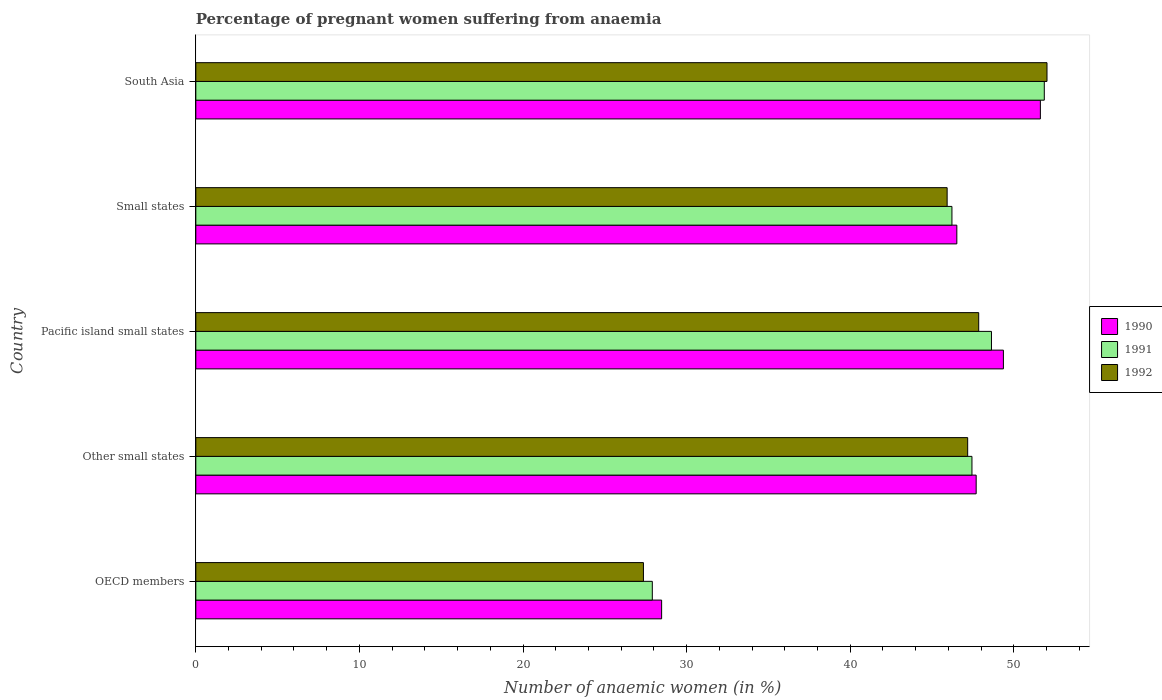How many groups of bars are there?
Your response must be concise. 5. How many bars are there on the 2nd tick from the top?
Give a very brief answer. 3. What is the label of the 5th group of bars from the top?
Your response must be concise. OECD members. In how many cases, is the number of bars for a given country not equal to the number of legend labels?
Ensure brevity in your answer.  0. What is the number of anaemic women in 1992 in Small states?
Ensure brevity in your answer.  45.93. Across all countries, what is the maximum number of anaemic women in 1992?
Keep it short and to the point. 52.03. Across all countries, what is the minimum number of anaemic women in 1992?
Offer a terse response. 27.36. What is the total number of anaemic women in 1992 in the graph?
Offer a terse response. 220.36. What is the difference between the number of anaemic women in 1992 in Other small states and that in Small states?
Ensure brevity in your answer.  1.26. What is the difference between the number of anaemic women in 1992 in Other small states and the number of anaemic women in 1991 in OECD members?
Provide a short and direct response. 19.28. What is the average number of anaemic women in 1992 per country?
Your response must be concise. 44.07. What is the difference between the number of anaemic women in 1992 and number of anaemic women in 1990 in OECD members?
Your answer should be compact. -1.11. In how many countries, is the number of anaemic women in 1991 greater than 52 %?
Offer a terse response. 0. What is the ratio of the number of anaemic women in 1990 in Pacific island small states to that in South Asia?
Give a very brief answer. 0.96. Is the number of anaemic women in 1991 in Other small states less than that in Pacific island small states?
Ensure brevity in your answer.  Yes. Is the difference between the number of anaemic women in 1992 in Other small states and South Asia greater than the difference between the number of anaemic women in 1990 in Other small states and South Asia?
Your answer should be compact. No. What is the difference between the highest and the second highest number of anaemic women in 1992?
Make the answer very short. 4.17. What is the difference between the highest and the lowest number of anaemic women in 1990?
Ensure brevity in your answer.  23.15. In how many countries, is the number of anaemic women in 1991 greater than the average number of anaemic women in 1991 taken over all countries?
Your answer should be very brief. 4. What does the 3rd bar from the bottom in Other small states represents?
Ensure brevity in your answer.  1992. How many bars are there?
Ensure brevity in your answer.  15. How many countries are there in the graph?
Provide a short and direct response. 5. Are the values on the major ticks of X-axis written in scientific E-notation?
Your answer should be compact. No. Does the graph contain grids?
Offer a terse response. No. Where does the legend appear in the graph?
Provide a short and direct response. Center right. What is the title of the graph?
Give a very brief answer. Percentage of pregnant women suffering from anaemia. What is the label or title of the X-axis?
Your answer should be very brief. Number of anaemic women (in %). What is the Number of anaemic women (in %) in 1990 in OECD members?
Provide a succinct answer. 28.47. What is the Number of anaemic women (in %) of 1991 in OECD members?
Your answer should be compact. 27.9. What is the Number of anaemic women (in %) of 1992 in OECD members?
Ensure brevity in your answer.  27.36. What is the Number of anaemic women (in %) of 1990 in Other small states?
Provide a succinct answer. 47.7. What is the Number of anaemic women (in %) of 1991 in Other small states?
Offer a very short reply. 47.44. What is the Number of anaemic women (in %) of 1992 in Other small states?
Your answer should be very brief. 47.18. What is the Number of anaemic women (in %) of 1990 in Pacific island small states?
Your response must be concise. 49.37. What is the Number of anaemic women (in %) in 1991 in Pacific island small states?
Provide a succinct answer. 48.64. What is the Number of anaemic women (in %) of 1992 in Pacific island small states?
Ensure brevity in your answer.  47.86. What is the Number of anaemic women (in %) of 1990 in Small states?
Ensure brevity in your answer.  46.52. What is the Number of anaemic women (in %) in 1991 in Small states?
Provide a succinct answer. 46.22. What is the Number of anaemic women (in %) in 1992 in Small states?
Provide a succinct answer. 45.93. What is the Number of anaemic women (in %) of 1990 in South Asia?
Keep it short and to the point. 51.63. What is the Number of anaemic women (in %) in 1991 in South Asia?
Keep it short and to the point. 51.87. What is the Number of anaemic women (in %) in 1992 in South Asia?
Make the answer very short. 52.03. Across all countries, what is the maximum Number of anaemic women (in %) in 1990?
Provide a short and direct response. 51.63. Across all countries, what is the maximum Number of anaemic women (in %) in 1991?
Your response must be concise. 51.87. Across all countries, what is the maximum Number of anaemic women (in %) of 1992?
Make the answer very short. 52.03. Across all countries, what is the minimum Number of anaemic women (in %) of 1990?
Your response must be concise. 28.47. Across all countries, what is the minimum Number of anaemic women (in %) of 1991?
Ensure brevity in your answer.  27.9. Across all countries, what is the minimum Number of anaemic women (in %) in 1992?
Your answer should be very brief. 27.36. What is the total Number of anaemic women (in %) of 1990 in the graph?
Provide a succinct answer. 223.69. What is the total Number of anaemic women (in %) in 1991 in the graph?
Your answer should be compact. 222.07. What is the total Number of anaemic women (in %) in 1992 in the graph?
Your answer should be compact. 220.36. What is the difference between the Number of anaemic women (in %) in 1990 in OECD members and that in Other small states?
Your answer should be compact. -19.23. What is the difference between the Number of anaemic women (in %) in 1991 in OECD members and that in Other small states?
Make the answer very short. -19.54. What is the difference between the Number of anaemic women (in %) of 1992 in OECD members and that in Other small states?
Give a very brief answer. -19.82. What is the difference between the Number of anaemic women (in %) of 1990 in OECD members and that in Pacific island small states?
Provide a short and direct response. -20.89. What is the difference between the Number of anaemic women (in %) of 1991 in OECD members and that in Pacific island small states?
Provide a succinct answer. -20.73. What is the difference between the Number of anaemic women (in %) in 1992 in OECD members and that in Pacific island small states?
Your response must be concise. -20.49. What is the difference between the Number of anaemic women (in %) of 1990 in OECD members and that in Small states?
Your answer should be compact. -18.05. What is the difference between the Number of anaemic women (in %) in 1991 in OECD members and that in Small states?
Your answer should be very brief. -18.32. What is the difference between the Number of anaemic women (in %) in 1992 in OECD members and that in Small states?
Ensure brevity in your answer.  -18.57. What is the difference between the Number of anaemic women (in %) in 1990 in OECD members and that in South Asia?
Keep it short and to the point. -23.15. What is the difference between the Number of anaemic women (in %) of 1991 in OECD members and that in South Asia?
Provide a short and direct response. -23.96. What is the difference between the Number of anaemic women (in %) of 1992 in OECD members and that in South Asia?
Offer a terse response. -24.67. What is the difference between the Number of anaemic women (in %) in 1990 in Other small states and that in Pacific island small states?
Your response must be concise. -1.66. What is the difference between the Number of anaemic women (in %) in 1991 in Other small states and that in Pacific island small states?
Ensure brevity in your answer.  -1.19. What is the difference between the Number of anaemic women (in %) of 1992 in Other small states and that in Pacific island small states?
Your response must be concise. -0.67. What is the difference between the Number of anaemic women (in %) in 1990 in Other small states and that in Small states?
Provide a succinct answer. 1.18. What is the difference between the Number of anaemic women (in %) of 1991 in Other small states and that in Small states?
Ensure brevity in your answer.  1.22. What is the difference between the Number of anaemic women (in %) in 1992 in Other small states and that in Small states?
Your response must be concise. 1.26. What is the difference between the Number of anaemic women (in %) of 1990 in Other small states and that in South Asia?
Your answer should be compact. -3.92. What is the difference between the Number of anaemic women (in %) of 1991 in Other small states and that in South Asia?
Your answer should be compact. -4.42. What is the difference between the Number of anaemic women (in %) in 1992 in Other small states and that in South Asia?
Your answer should be compact. -4.85. What is the difference between the Number of anaemic women (in %) in 1990 in Pacific island small states and that in Small states?
Offer a terse response. 2.85. What is the difference between the Number of anaemic women (in %) in 1991 in Pacific island small states and that in Small states?
Keep it short and to the point. 2.42. What is the difference between the Number of anaemic women (in %) in 1992 in Pacific island small states and that in Small states?
Offer a very short reply. 1.93. What is the difference between the Number of anaemic women (in %) of 1990 in Pacific island small states and that in South Asia?
Keep it short and to the point. -2.26. What is the difference between the Number of anaemic women (in %) of 1991 in Pacific island small states and that in South Asia?
Your response must be concise. -3.23. What is the difference between the Number of anaemic women (in %) in 1992 in Pacific island small states and that in South Asia?
Your answer should be very brief. -4.17. What is the difference between the Number of anaemic women (in %) in 1990 in Small states and that in South Asia?
Your answer should be compact. -5.11. What is the difference between the Number of anaemic women (in %) of 1991 in Small states and that in South Asia?
Offer a terse response. -5.65. What is the difference between the Number of anaemic women (in %) of 1992 in Small states and that in South Asia?
Your answer should be compact. -6.1. What is the difference between the Number of anaemic women (in %) of 1990 in OECD members and the Number of anaemic women (in %) of 1991 in Other small states?
Keep it short and to the point. -18.97. What is the difference between the Number of anaemic women (in %) of 1990 in OECD members and the Number of anaemic women (in %) of 1992 in Other small states?
Your response must be concise. -18.71. What is the difference between the Number of anaemic women (in %) in 1991 in OECD members and the Number of anaemic women (in %) in 1992 in Other small states?
Provide a short and direct response. -19.28. What is the difference between the Number of anaemic women (in %) of 1990 in OECD members and the Number of anaemic women (in %) of 1991 in Pacific island small states?
Offer a very short reply. -20.16. What is the difference between the Number of anaemic women (in %) of 1990 in OECD members and the Number of anaemic women (in %) of 1992 in Pacific island small states?
Your answer should be very brief. -19.38. What is the difference between the Number of anaemic women (in %) of 1991 in OECD members and the Number of anaemic women (in %) of 1992 in Pacific island small states?
Your answer should be very brief. -19.95. What is the difference between the Number of anaemic women (in %) of 1990 in OECD members and the Number of anaemic women (in %) of 1991 in Small states?
Your answer should be very brief. -17.75. What is the difference between the Number of anaemic women (in %) of 1990 in OECD members and the Number of anaemic women (in %) of 1992 in Small states?
Offer a very short reply. -17.45. What is the difference between the Number of anaemic women (in %) in 1991 in OECD members and the Number of anaemic women (in %) in 1992 in Small states?
Provide a succinct answer. -18.02. What is the difference between the Number of anaemic women (in %) of 1990 in OECD members and the Number of anaemic women (in %) of 1991 in South Asia?
Your answer should be compact. -23.39. What is the difference between the Number of anaemic women (in %) of 1990 in OECD members and the Number of anaemic women (in %) of 1992 in South Asia?
Your response must be concise. -23.56. What is the difference between the Number of anaemic women (in %) in 1991 in OECD members and the Number of anaemic women (in %) in 1992 in South Asia?
Provide a succinct answer. -24.13. What is the difference between the Number of anaemic women (in %) of 1990 in Other small states and the Number of anaemic women (in %) of 1991 in Pacific island small states?
Your answer should be compact. -0.94. What is the difference between the Number of anaemic women (in %) in 1990 in Other small states and the Number of anaemic women (in %) in 1992 in Pacific island small states?
Your answer should be compact. -0.15. What is the difference between the Number of anaemic women (in %) of 1991 in Other small states and the Number of anaemic women (in %) of 1992 in Pacific island small states?
Your response must be concise. -0.41. What is the difference between the Number of anaemic women (in %) in 1990 in Other small states and the Number of anaemic women (in %) in 1991 in Small states?
Make the answer very short. 1.48. What is the difference between the Number of anaemic women (in %) of 1990 in Other small states and the Number of anaemic women (in %) of 1992 in Small states?
Keep it short and to the point. 1.77. What is the difference between the Number of anaemic women (in %) in 1991 in Other small states and the Number of anaemic women (in %) in 1992 in Small states?
Give a very brief answer. 1.52. What is the difference between the Number of anaemic women (in %) of 1990 in Other small states and the Number of anaemic women (in %) of 1991 in South Asia?
Provide a succinct answer. -4.16. What is the difference between the Number of anaemic women (in %) in 1990 in Other small states and the Number of anaemic women (in %) in 1992 in South Asia?
Provide a short and direct response. -4.33. What is the difference between the Number of anaemic women (in %) in 1991 in Other small states and the Number of anaemic women (in %) in 1992 in South Asia?
Offer a terse response. -4.59. What is the difference between the Number of anaemic women (in %) of 1990 in Pacific island small states and the Number of anaemic women (in %) of 1991 in Small states?
Offer a terse response. 3.15. What is the difference between the Number of anaemic women (in %) in 1990 in Pacific island small states and the Number of anaemic women (in %) in 1992 in Small states?
Make the answer very short. 3.44. What is the difference between the Number of anaemic women (in %) of 1991 in Pacific island small states and the Number of anaemic women (in %) of 1992 in Small states?
Provide a succinct answer. 2.71. What is the difference between the Number of anaemic women (in %) of 1990 in Pacific island small states and the Number of anaemic women (in %) of 1991 in South Asia?
Provide a short and direct response. -2.5. What is the difference between the Number of anaemic women (in %) of 1990 in Pacific island small states and the Number of anaemic women (in %) of 1992 in South Asia?
Offer a very short reply. -2.66. What is the difference between the Number of anaemic women (in %) of 1991 in Pacific island small states and the Number of anaemic women (in %) of 1992 in South Asia?
Offer a terse response. -3.39. What is the difference between the Number of anaemic women (in %) of 1990 in Small states and the Number of anaemic women (in %) of 1991 in South Asia?
Offer a very short reply. -5.35. What is the difference between the Number of anaemic women (in %) in 1990 in Small states and the Number of anaemic women (in %) in 1992 in South Asia?
Keep it short and to the point. -5.51. What is the difference between the Number of anaemic women (in %) in 1991 in Small states and the Number of anaemic women (in %) in 1992 in South Asia?
Provide a succinct answer. -5.81. What is the average Number of anaemic women (in %) of 1990 per country?
Offer a terse response. 44.74. What is the average Number of anaemic women (in %) of 1991 per country?
Your answer should be compact. 44.41. What is the average Number of anaemic women (in %) in 1992 per country?
Your answer should be compact. 44.07. What is the difference between the Number of anaemic women (in %) in 1990 and Number of anaemic women (in %) in 1991 in OECD members?
Your answer should be compact. 0.57. What is the difference between the Number of anaemic women (in %) of 1990 and Number of anaemic women (in %) of 1992 in OECD members?
Make the answer very short. 1.11. What is the difference between the Number of anaemic women (in %) of 1991 and Number of anaemic women (in %) of 1992 in OECD members?
Your response must be concise. 0.54. What is the difference between the Number of anaemic women (in %) of 1990 and Number of anaemic women (in %) of 1991 in Other small states?
Give a very brief answer. 0.26. What is the difference between the Number of anaemic women (in %) of 1990 and Number of anaemic women (in %) of 1992 in Other small states?
Keep it short and to the point. 0.52. What is the difference between the Number of anaemic women (in %) of 1991 and Number of anaemic women (in %) of 1992 in Other small states?
Make the answer very short. 0.26. What is the difference between the Number of anaemic women (in %) in 1990 and Number of anaemic women (in %) in 1991 in Pacific island small states?
Keep it short and to the point. 0.73. What is the difference between the Number of anaemic women (in %) in 1990 and Number of anaemic women (in %) in 1992 in Pacific island small states?
Provide a succinct answer. 1.51. What is the difference between the Number of anaemic women (in %) of 1991 and Number of anaemic women (in %) of 1992 in Pacific island small states?
Give a very brief answer. 0.78. What is the difference between the Number of anaemic women (in %) in 1990 and Number of anaemic women (in %) in 1991 in Small states?
Ensure brevity in your answer.  0.3. What is the difference between the Number of anaemic women (in %) of 1990 and Number of anaemic women (in %) of 1992 in Small states?
Offer a very short reply. 0.59. What is the difference between the Number of anaemic women (in %) in 1991 and Number of anaemic women (in %) in 1992 in Small states?
Provide a short and direct response. 0.29. What is the difference between the Number of anaemic women (in %) of 1990 and Number of anaemic women (in %) of 1991 in South Asia?
Offer a very short reply. -0.24. What is the difference between the Number of anaemic women (in %) of 1990 and Number of anaemic women (in %) of 1992 in South Asia?
Provide a short and direct response. -0.4. What is the difference between the Number of anaemic women (in %) of 1991 and Number of anaemic women (in %) of 1992 in South Asia?
Your answer should be compact. -0.16. What is the ratio of the Number of anaemic women (in %) in 1990 in OECD members to that in Other small states?
Keep it short and to the point. 0.6. What is the ratio of the Number of anaemic women (in %) in 1991 in OECD members to that in Other small states?
Offer a very short reply. 0.59. What is the ratio of the Number of anaemic women (in %) of 1992 in OECD members to that in Other small states?
Your answer should be compact. 0.58. What is the ratio of the Number of anaemic women (in %) of 1990 in OECD members to that in Pacific island small states?
Your answer should be very brief. 0.58. What is the ratio of the Number of anaemic women (in %) in 1991 in OECD members to that in Pacific island small states?
Provide a succinct answer. 0.57. What is the ratio of the Number of anaemic women (in %) in 1992 in OECD members to that in Pacific island small states?
Offer a terse response. 0.57. What is the ratio of the Number of anaemic women (in %) of 1990 in OECD members to that in Small states?
Your answer should be compact. 0.61. What is the ratio of the Number of anaemic women (in %) in 1991 in OECD members to that in Small states?
Give a very brief answer. 0.6. What is the ratio of the Number of anaemic women (in %) in 1992 in OECD members to that in Small states?
Keep it short and to the point. 0.6. What is the ratio of the Number of anaemic women (in %) of 1990 in OECD members to that in South Asia?
Your response must be concise. 0.55. What is the ratio of the Number of anaemic women (in %) of 1991 in OECD members to that in South Asia?
Your answer should be very brief. 0.54. What is the ratio of the Number of anaemic women (in %) in 1992 in OECD members to that in South Asia?
Your answer should be compact. 0.53. What is the ratio of the Number of anaemic women (in %) in 1990 in Other small states to that in Pacific island small states?
Your answer should be compact. 0.97. What is the ratio of the Number of anaemic women (in %) in 1991 in Other small states to that in Pacific island small states?
Keep it short and to the point. 0.98. What is the ratio of the Number of anaemic women (in %) of 1992 in Other small states to that in Pacific island small states?
Your response must be concise. 0.99. What is the ratio of the Number of anaemic women (in %) in 1990 in Other small states to that in Small states?
Offer a very short reply. 1.03. What is the ratio of the Number of anaemic women (in %) of 1991 in Other small states to that in Small states?
Offer a very short reply. 1.03. What is the ratio of the Number of anaemic women (in %) in 1992 in Other small states to that in Small states?
Your answer should be compact. 1.03. What is the ratio of the Number of anaemic women (in %) in 1990 in Other small states to that in South Asia?
Your answer should be compact. 0.92. What is the ratio of the Number of anaemic women (in %) of 1991 in Other small states to that in South Asia?
Make the answer very short. 0.91. What is the ratio of the Number of anaemic women (in %) in 1992 in Other small states to that in South Asia?
Your answer should be very brief. 0.91. What is the ratio of the Number of anaemic women (in %) in 1990 in Pacific island small states to that in Small states?
Ensure brevity in your answer.  1.06. What is the ratio of the Number of anaemic women (in %) in 1991 in Pacific island small states to that in Small states?
Provide a short and direct response. 1.05. What is the ratio of the Number of anaemic women (in %) of 1992 in Pacific island small states to that in Small states?
Your answer should be compact. 1.04. What is the ratio of the Number of anaemic women (in %) in 1990 in Pacific island small states to that in South Asia?
Your response must be concise. 0.96. What is the ratio of the Number of anaemic women (in %) of 1991 in Pacific island small states to that in South Asia?
Ensure brevity in your answer.  0.94. What is the ratio of the Number of anaemic women (in %) in 1992 in Pacific island small states to that in South Asia?
Your answer should be very brief. 0.92. What is the ratio of the Number of anaemic women (in %) in 1990 in Small states to that in South Asia?
Give a very brief answer. 0.9. What is the ratio of the Number of anaemic women (in %) of 1991 in Small states to that in South Asia?
Keep it short and to the point. 0.89. What is the ratio of the Number of anaemic women (in %) in 1992 in Small states to that in South Asia?
Provide a short and direct response. 0.88. What is the difference between the highest and the second highest Number of anaemic women (in %) of 1990?
Offer a terse response. 2.26. What is the difference between the highest and the second highest Number of anaemic women (in %) in 1991?
Ensure brevity in your answer.  3.23. What is the difference between the highest and the second highest Number of anaemic women (in %) in 1992?
Offer a terse response. 4.17. What is the difference between the highest and the lowest Number of anaemic women (in %) in 1990?
Ensure brevity in your answer.  23.15. What is the difference between the highest and the lowest Number of anaemic women (in %) of 1991?
Provide a succinct answer. 23.96. What is the difference between the highest and the lowest Number of anaemic women (in %) of 1992?
Your answer should be compact. 24.67. 